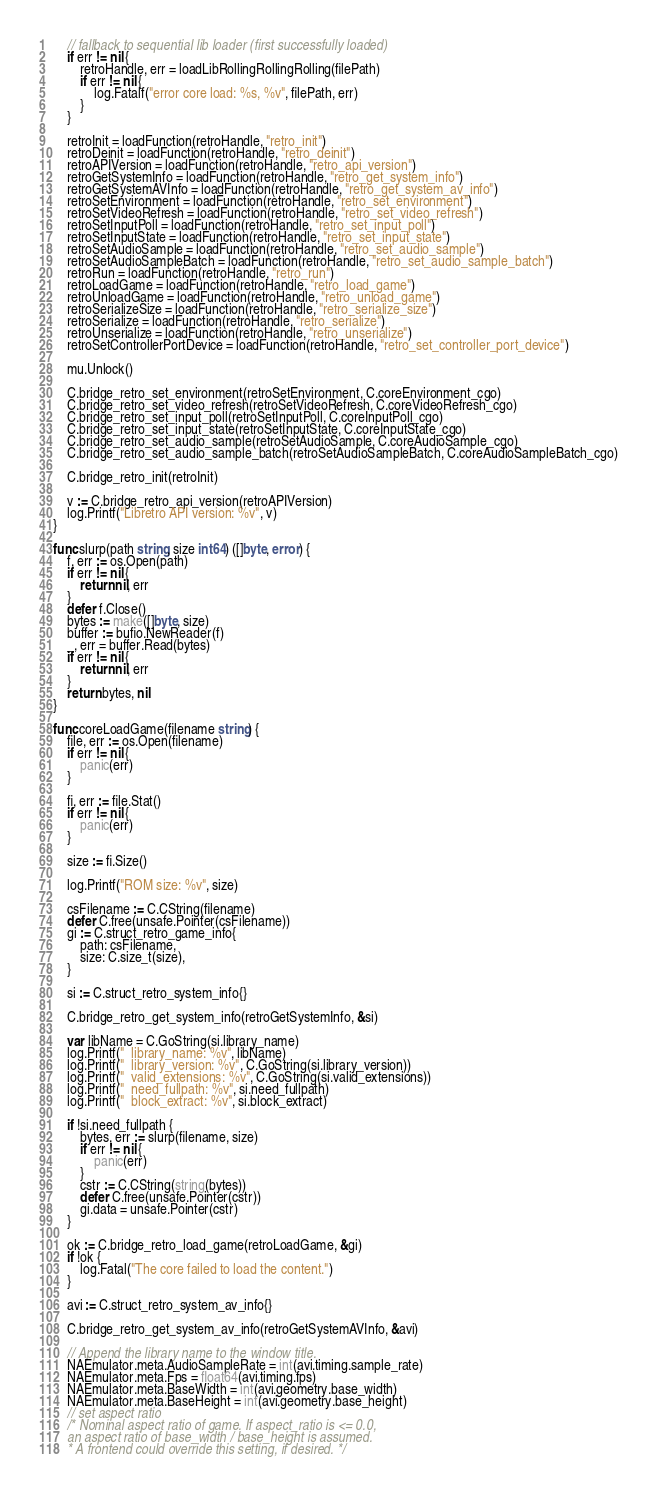<code> <loc_0><loc_0><loc_500><loc_500><_Go_>	// fallback to sequential lib loader (first successfully loaded)
	if err != nil {
		retroHandle, err = loadLibRollingRollingRolling(filePath)
		if err != nil {
			log.Fatalf("error core load: %s, %v", filePath, err)
		}
	}

	retroInit = loadFunction(retroHandle, "retro_init")
	retroDeinit = loadFunction(retroHandle, "retro_deinit")
	retroAPIVersion = loadFunction(retroHandle, "retro_api_version")
	retroGetSystemInfo = loadFunction(retroHandle, "retro_get_system_info")
	retroGetSystemAVInfo = loadFunction(retroHandle, "retro_get_system_av_info")
	retroSetEnvironment = loadFunction(retroHandle, "retro_set_environment")
	retroSetVideoRefresh = loadFunction(retroHandle, "retro_set_video_refresh")
	retroSetInputPoll = loadFunction(retroHandle, "retro_set_input_poll")
	retroSetInputState = loadFunction(retroHandle, "retro_set_input_state")
	retroSetAudioSample = loadFunction(retroHandle, "retro_set_audio_sample")
	retroSetAudioSampleBatch = loadFunction(retroHandle, "retro_set_audio_sample_batch")
	retroRun = loadFunction(retroHandle, "retro_run")
	retroLoadGame = loadFunction(retroHandle, "retro_load_game")
	retroUnloadGame = loadFunction(retroHandle, "retro_unload_game")
	retroSerializeSize = loadFunction(retroHandle, "retro_serialize_size")
	retroSerialize = loadFunction(retroHandle, "retro_serialize")
	retroUnserialize = loadFunction(retroHandle, "retro_unserialize")
	retroSetControllerPortDevice = loadFunction(retroHandle, "retro_set_controller_port_device")

	mu.Unlock()

	C.bridge_retro_set_environment(retroSetEnvironment, C.coreEnvironment_cgo)
	C.bridge_retro_set_video_refresh(retroSetVideoRefresh, C.coreVideoRefresh_cgo)
	C.bridge_retro_set_input_poll(retroSetInputPoll, C.coreInputPoll_cgo)
	C.bridge_retro_set_input_state(retroSetInputState, C.coreInputState_cgo)
	C.bridge_retro_set_audio_sample(retroSetAudioSample, C.coreAudioSample_cgo)
	C.bridge_retro_set_audio_sample_batch(retroSetAudioSampleBatch, C.coreAudioSampleBatch_cgo)

	C.bridge_retro_init(retroInit)

	v := C.bridge_retro_api_version(retroAPIVersion)
	log.Printf("Libretro API version: %v", v)
}

func slurp(path string, size int64) ([]byte, error) {
	f, err := os.Open(path)
	if err != nil {
		return nil, err
	}
	defer f.Close()
	bytes := make([]byte, size)
	buffer := bufio.NewReader(f)
	_, err = buffer.Read(bytes)
	if err != nil {
		return nil, err
	}
	return bytes, nil
}

func coreLoadGame(filename string) {
	file, err := os.Open(filename)
	if err != nil {
		panic(err)
	}

	fi, err := file.Stat()
	if err != nil {
		panic(err)
	}

	size := fi.Size()

	log.Printf("ROM size: %v", size)

	csFilename := C.CString(filename)
	defer C.free(unsafe.Pointer(csFilename))
	gi := C.struct_retro_game_info{
		path: csFilename,
		size: C.size_t(size),
	}

	si := C.struct_retro_system_info{}

	C.bridge_retro_get_system_info(retroGetSystemInfo, &si)

	var libName = C.GoString(si.library_name)
	log.Printf("  library_name: %v", libName)
	log.Printf("  library_version: %v", C.GoString(si.library_version))
	log.Printf("  valid_extensions: %v", C.GoString(si.valid_extensions))
	log.Printf("  need_fullpath: %v", si.need_fullpath)
	log.Printf("  block_extract: %v", si.block_extract)

	if !si.need_fullpath {
		bytes, err := slurp(filename, size)
		if err != nil {
			panic(err)
		}
		cstr := C.CString(string(bytes))
		defer C.free(unsafe.Pointer(cstr))
		gi.data = unsafe.Pointer(cstr)
	}

	ok := C.bridge_retro_load_game(retroLoadGame, &gi)
	if !ok {
		log.Fatal("The core failed to load the content.")
	}

	avi := C.struct_retro_system_av_info{}

	C.bridge_retro_get_system_av_info(retroGetSystemAVInfo, &avi)

	// Append the library name to the window title.
	NAEmulator.meta.AudioSampleRate = int(avi.timing.sample_rate)
	NAEmulator.meta.Fps = float64(avi.timing.fps)
	NAEmulator.meta.BaseWidth = int(avi.geometry.base_width)
	NAEmulator.meta.BaseHeight = int(avi.geometry.base_height)
	// set aspect ratio
	/* Nominal aspect ratio of game. If aspect_ratio is <= 0.0,
	an aspect ratio of base_width / base_height is assumed.
	* A frontend could override this setting, if desired. */</code> 